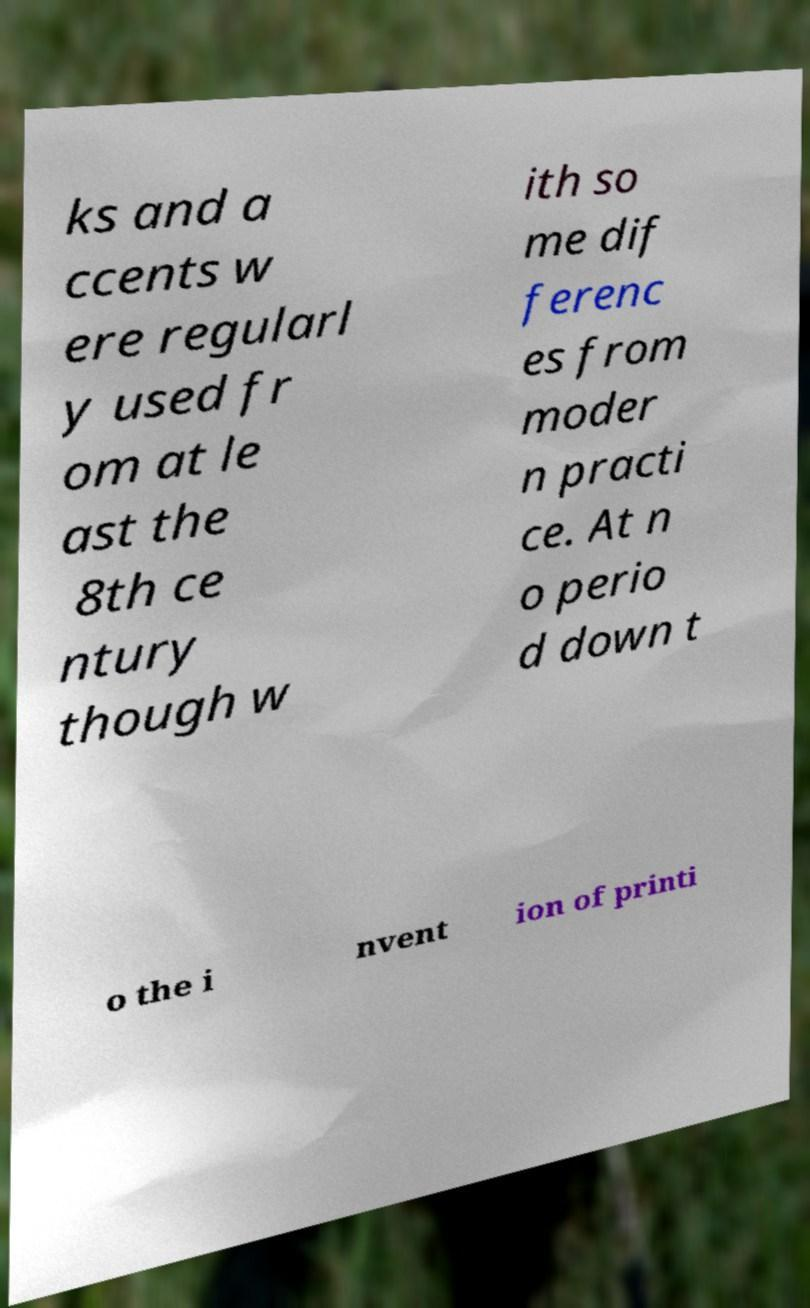Can you accurately transcribe the text from the provided image for me? ks and a ccents w ere regularl y used fr om at le ast the 8th ce ntury though w ith so me dif ferenc es from moder n practi ce. At n o perio d down t o the i nvent ion of printi 